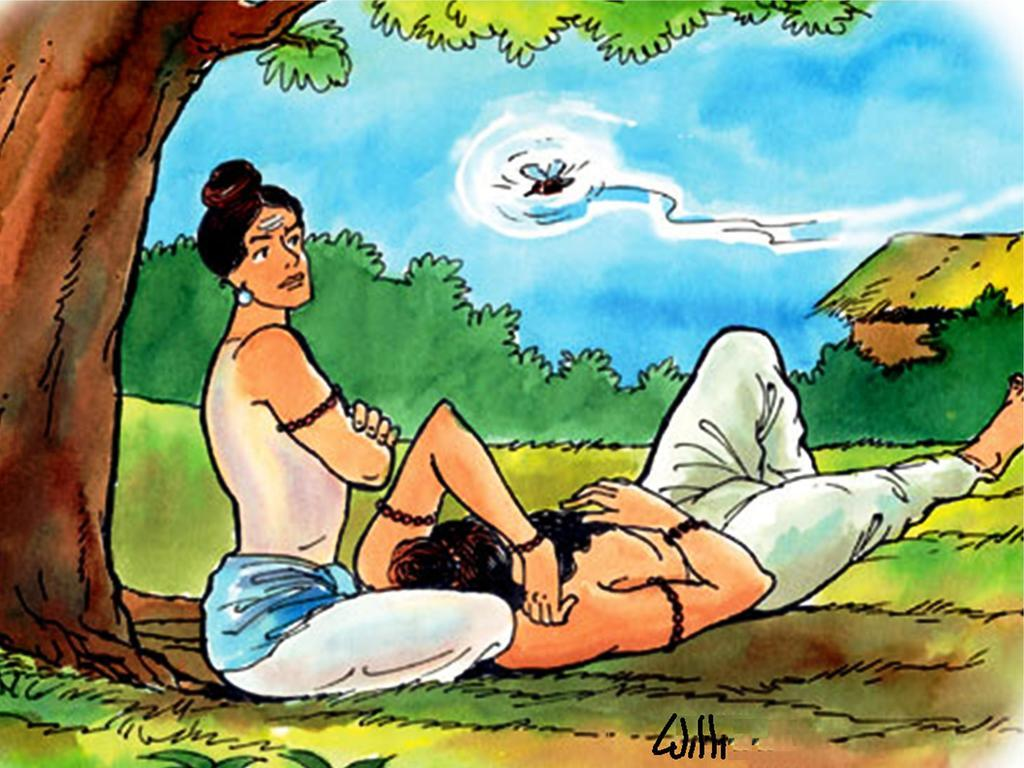What is the main subject of the image? There is a painting in the image. What can be seen in the painting? The painting contains two people. What is located to the left of the painting? There is a tree to the left of the painting. What can be seen in the background of the painting? There is a house, plants, a bird, and a sky in the background of the painting. How many spiders are crawling on the tongue in the image? There are no spiders or tongues present in the image. 